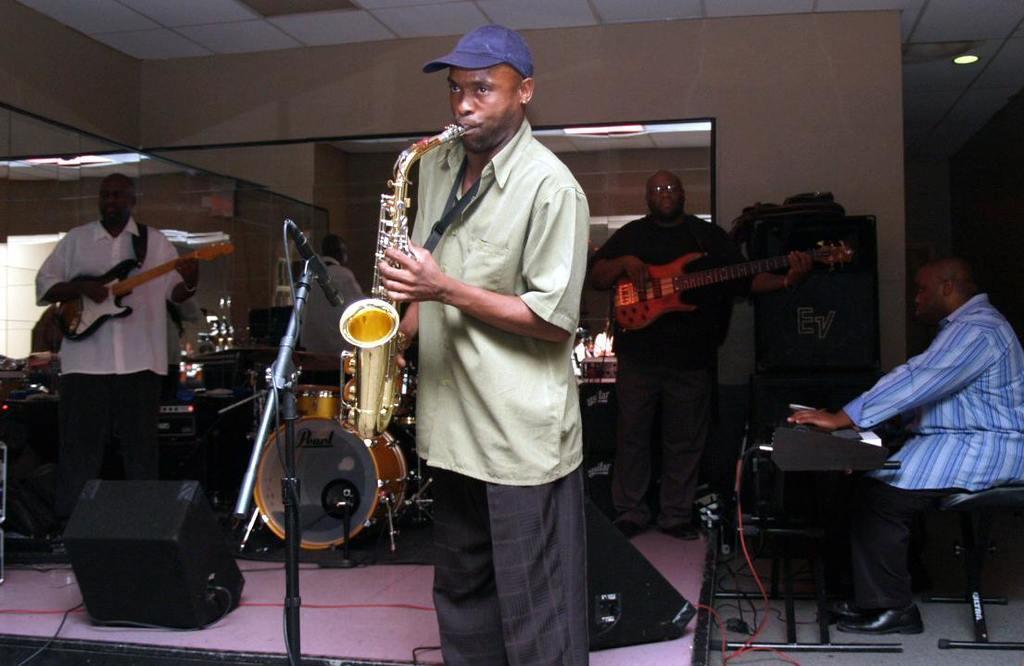How would you summarize this image in a sentence or two? In this picture we can see a man who is playing a trumpet. Here we can see two persons are playing guitar. And these are some musical instruments. On the background there is a wall and this is light. 